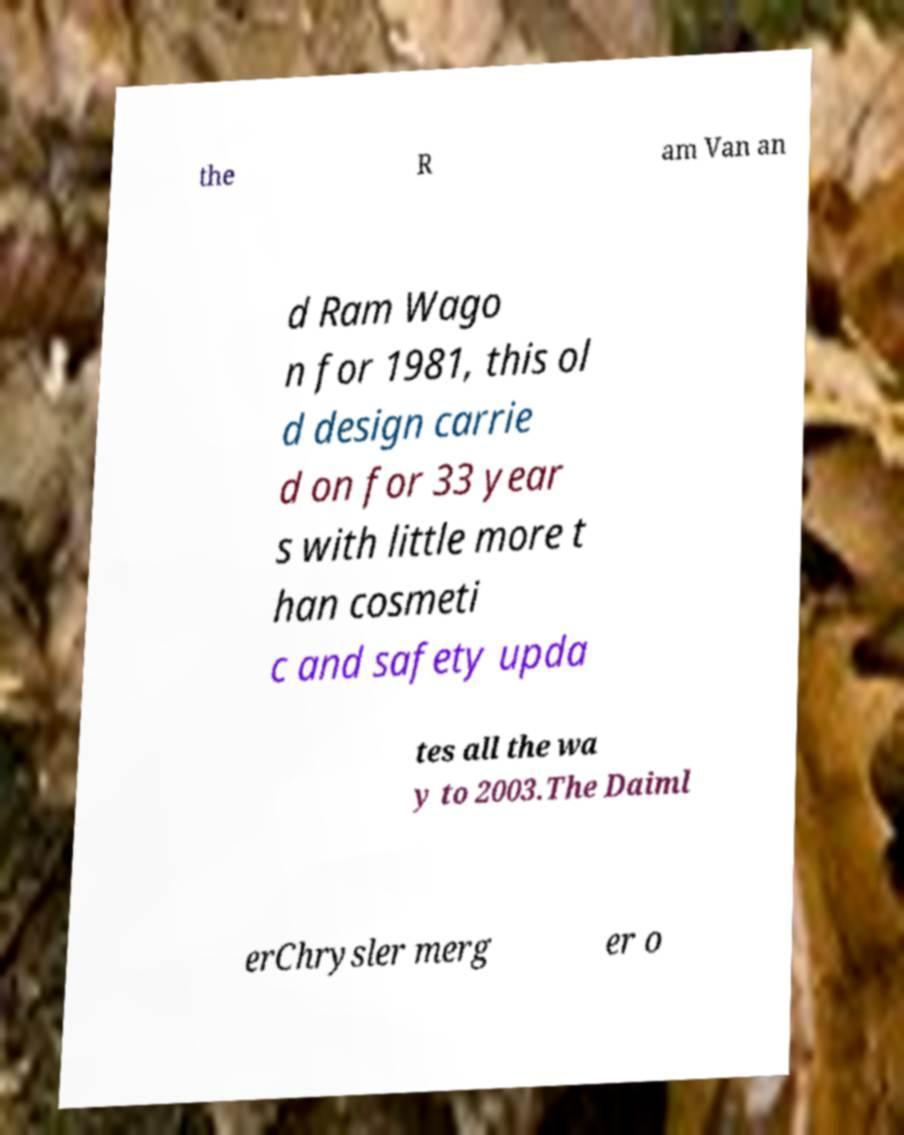Could you assist in decoding the text presented in this image and type it out clearly? the R am Van an d Ram Wago n for 1981, this ol d design carrie d on for 33 year s with little more t han cosmeti c and safety upda tes all the wa y to 2003.The Daiml erChrysler merg er o 